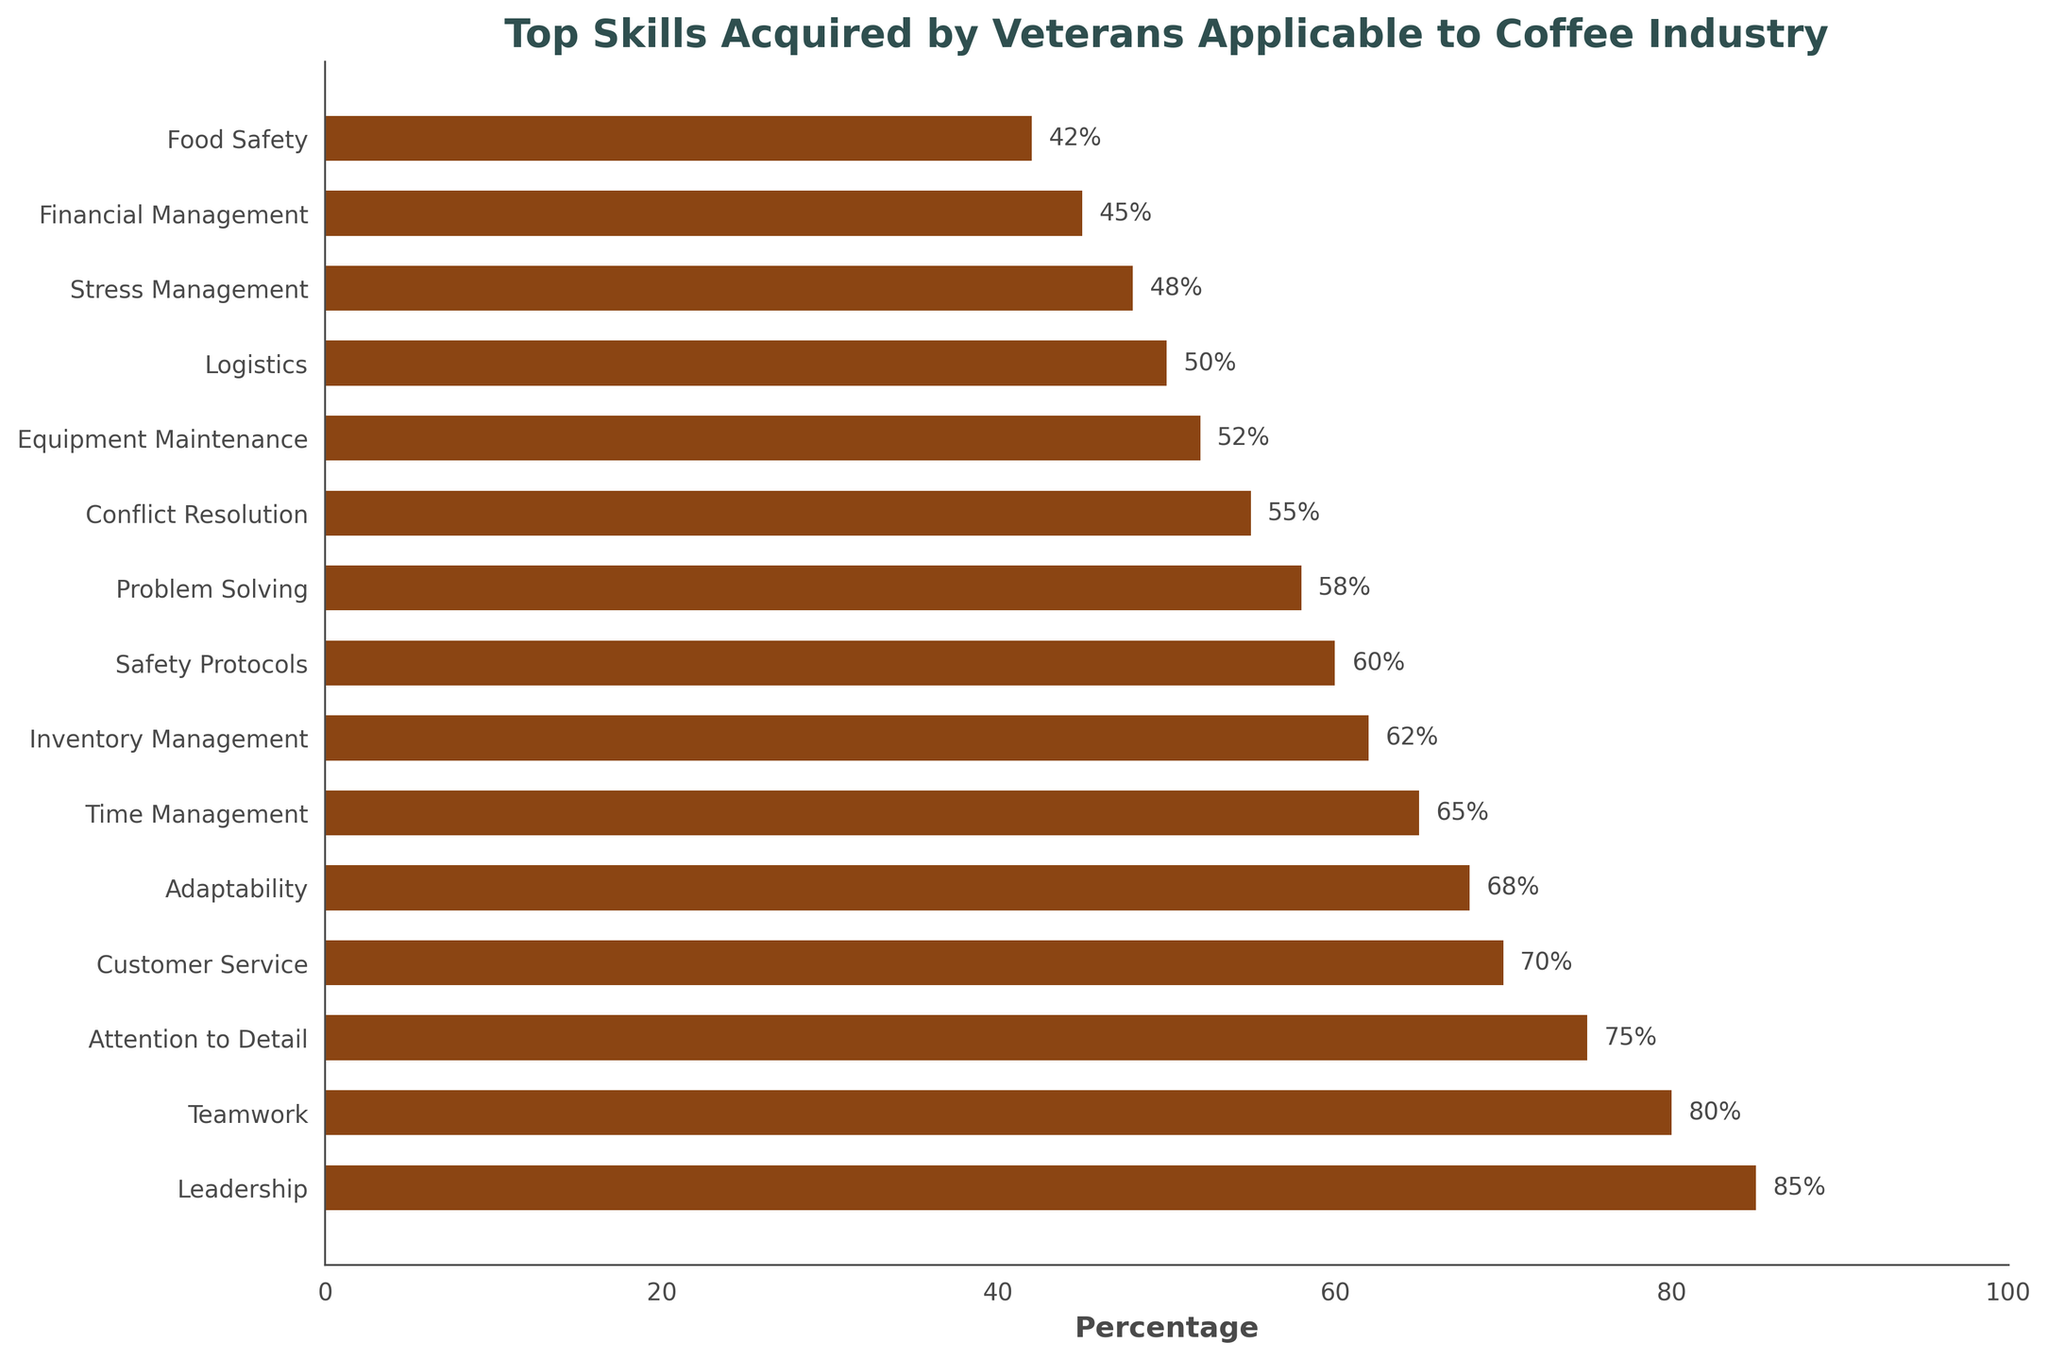What's the top skill acquired by veterans applicable to the coffee industry? The skill with the highest percentage on the bar chart is considered the top skill. By looking at the bars, "Leadership" has the highest percentage of 85%.
Answer: Leadership Which skills have percentages above 70%? Skills with bars extending beyond the 70% mark include "Leadership," "Teamwork," "Attention to Detail," and "Customer Service." These can be identified from their lengths surpassing the 70% line.
Answer: Leadership, Teamwork, Attention to Detail, Customer Service What's the difference in percentage between "Leadership" and "Financial Management"? Subtract the percentage of "Financial Management" from that of "Leadership." From the chart, "Leadership" has 85%, and "Financial Management" has 45%, making the difference 85% - 45% = 40%.
Answer: 40% Which skill has the lowest percentage and by how much is it lower than "Leadership"? The skill with the shortest bar is considered the lowest. "Food Safety" has the lowest percentage of 42%. The difference can be calculated by subtracting 42% from 85% (percentage for "Leadership"), resulting in 85% - 42% = 43%.
Answer: Food Safety, 43% How many skills have percentages between 60% and 70%? Count the number of bars that extend within the 60%-70% range. The skills that fall in this range are "Inventory Management" (62%) and "Safety Protocols" (60%). Therefore, the total number is 2.
Answer: 2 What is the combined percentage of "Teamwork" and "Problem Solving"? Add the percentages of "Teamwork" and "Problem Solving." "Teamwork" has 80%, and "Problem Solving" has 58%. The combined total is 80% + 58% = 138%.
Answer: 138% Which is greater – the percentage of "Adaptability" or the percentage of "Logistics"? Compare the percentages of "Adaptability" (68%) and "Logistics" (50%). Since 68% is greater than 50%, "Adaptability" has the higher percentage.
Answer: Adaptability What percentage of skills listed are related to customer and team interaction, and how do you determine it? Identify the skills related to customer and team interaction: "Leadership," "Teamwork," "Customer Service," "Conflict Resolution," and "Stress Management." Count these skills (5 out of 15) and convert to percentage, (5/15) * 100% = 33.33%.
Answer: 33.33% What skills fall below the average percentage of all listed skills? First, find the average percentage by summing all skill percentages and dividing by the total number of skills. These total at 995% for 15 skills. The average is 995% / 15 = 66.33%. Skills below this average are "Time Management," "Inventory Management," "Safety Protocols," "Problem Solving," "Conflict Resolution," "Equipment Maintenance," "Logistics," "Stress Management," "Financial Management," and "Food Safety."
Answer: Time Management, Inventory Management, Safety Protocols, Problem Solving, Conflict Resolution, Equipment Maintenance, Logistics, Stress Management, Financial Management, Food Safety 